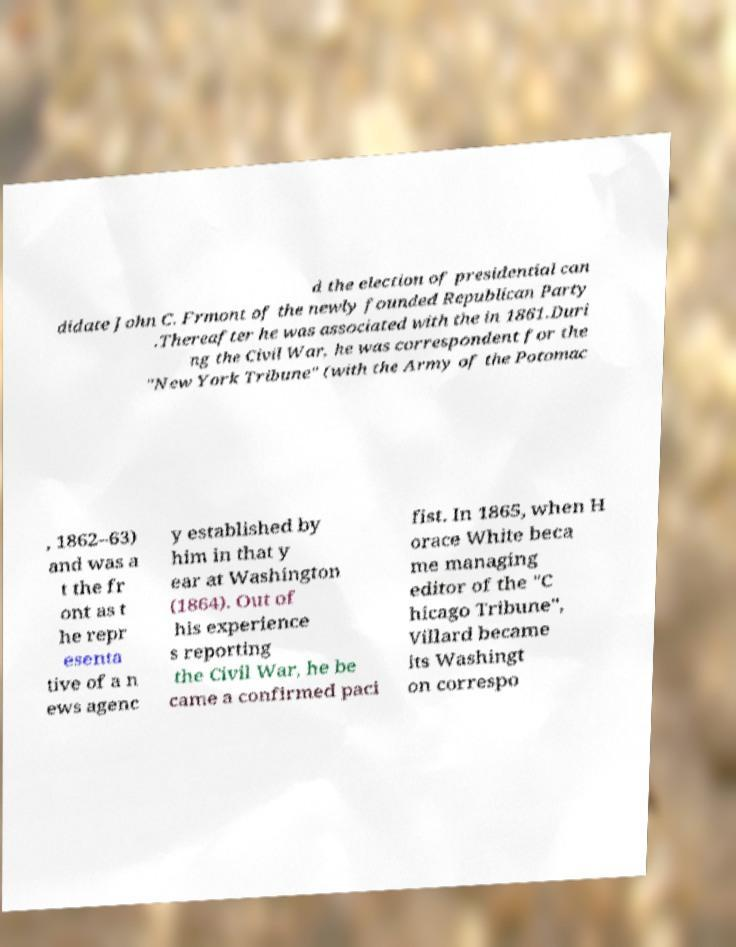For documentation purposes, I need the text within this image transcribed. Could you provide that? d the election of presidential can didate John C. Frmont of the newly founded Republican Party .Thereafter he was associated with the in 1861.Duri ng the Civil War, he was correspondent for the "New York Tribune" (with the Army of the Potomac , 1862–63) and was a t the fr ont as t he repr esenta tive of a n ews agenc y established by him in that y ear at Washington (1864). Out of his experience s reporting the Civil War, he be came a confirmed paci fist. In 1865, when H orace White beca me managing editor of the "C hicago Tribune", Villard became its Washingt on correspo 